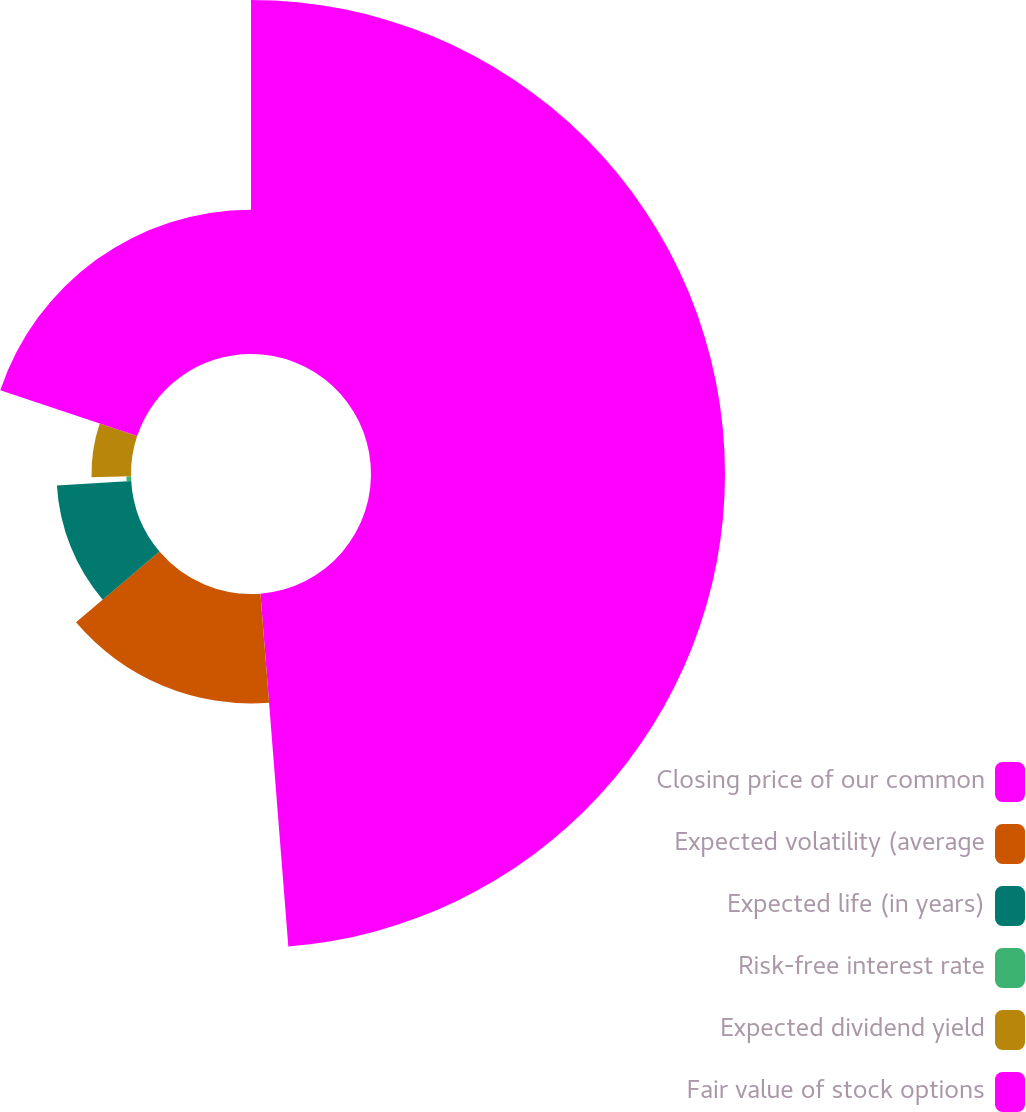<chart> <loc_0><loc_0><loc_500><loc_500><pie_chart><fcel>Closing price of our common<fcel>Expected volatility (average<fcel>Expected life (in years)<fcel>Risk-free interest rate<fcel>Expected dividend yield<fcel>Fair value of stock options<nl><fcel>48.74%<fcel>15.06%<fcel>10.25%<fcel>0.63%<fcel>5.44%<fcel>19.87%<nl></chart> 